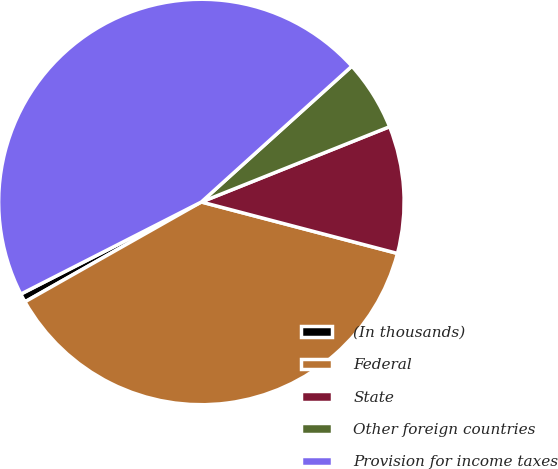Convert chart. <chart><loc_0><loc_0><loc_500><loc_500><pie_chart><fcel>(In thousands)<fcel>Federal<fcel>State<fcel>Other foreign countries<fcel>Provision for income taxes<nl><fcel>0.69%<fcel>37.72%<fcel>10.14%<fcel>5.63%<fcel>45.82%<nl></chart> 